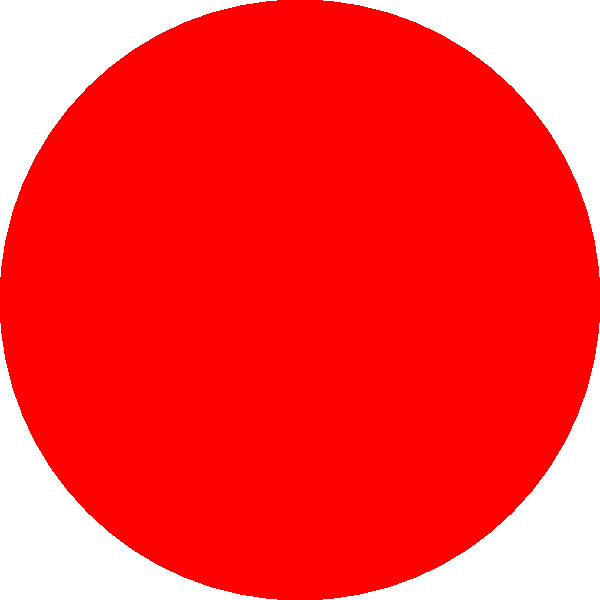You will be shown a complex image for 5 seconds. After the image disappears, you will be asked to recall specific details. Which shape is filled with the color red? 1. The image contains multiple geometric shapes and colors.
2. The central shape is a circle, which is filled with red.
3. There is also a blue rectangle in the background.
4. Two diagonal lines cross the image in green and orange.
5. The question specifically asks about the shape filled with red.
6. Recalling from the brief viewing, the red-filled shape is the circle.
Answer: Circle 